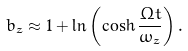<formula> <loc_0><loc_0><loc_500><loc_500>b _ { z } \approx 1 + \ln { \left ( \cosh { \frac { \Omega t } { \omega _ { z } } } \right ) } \, .</formula> 